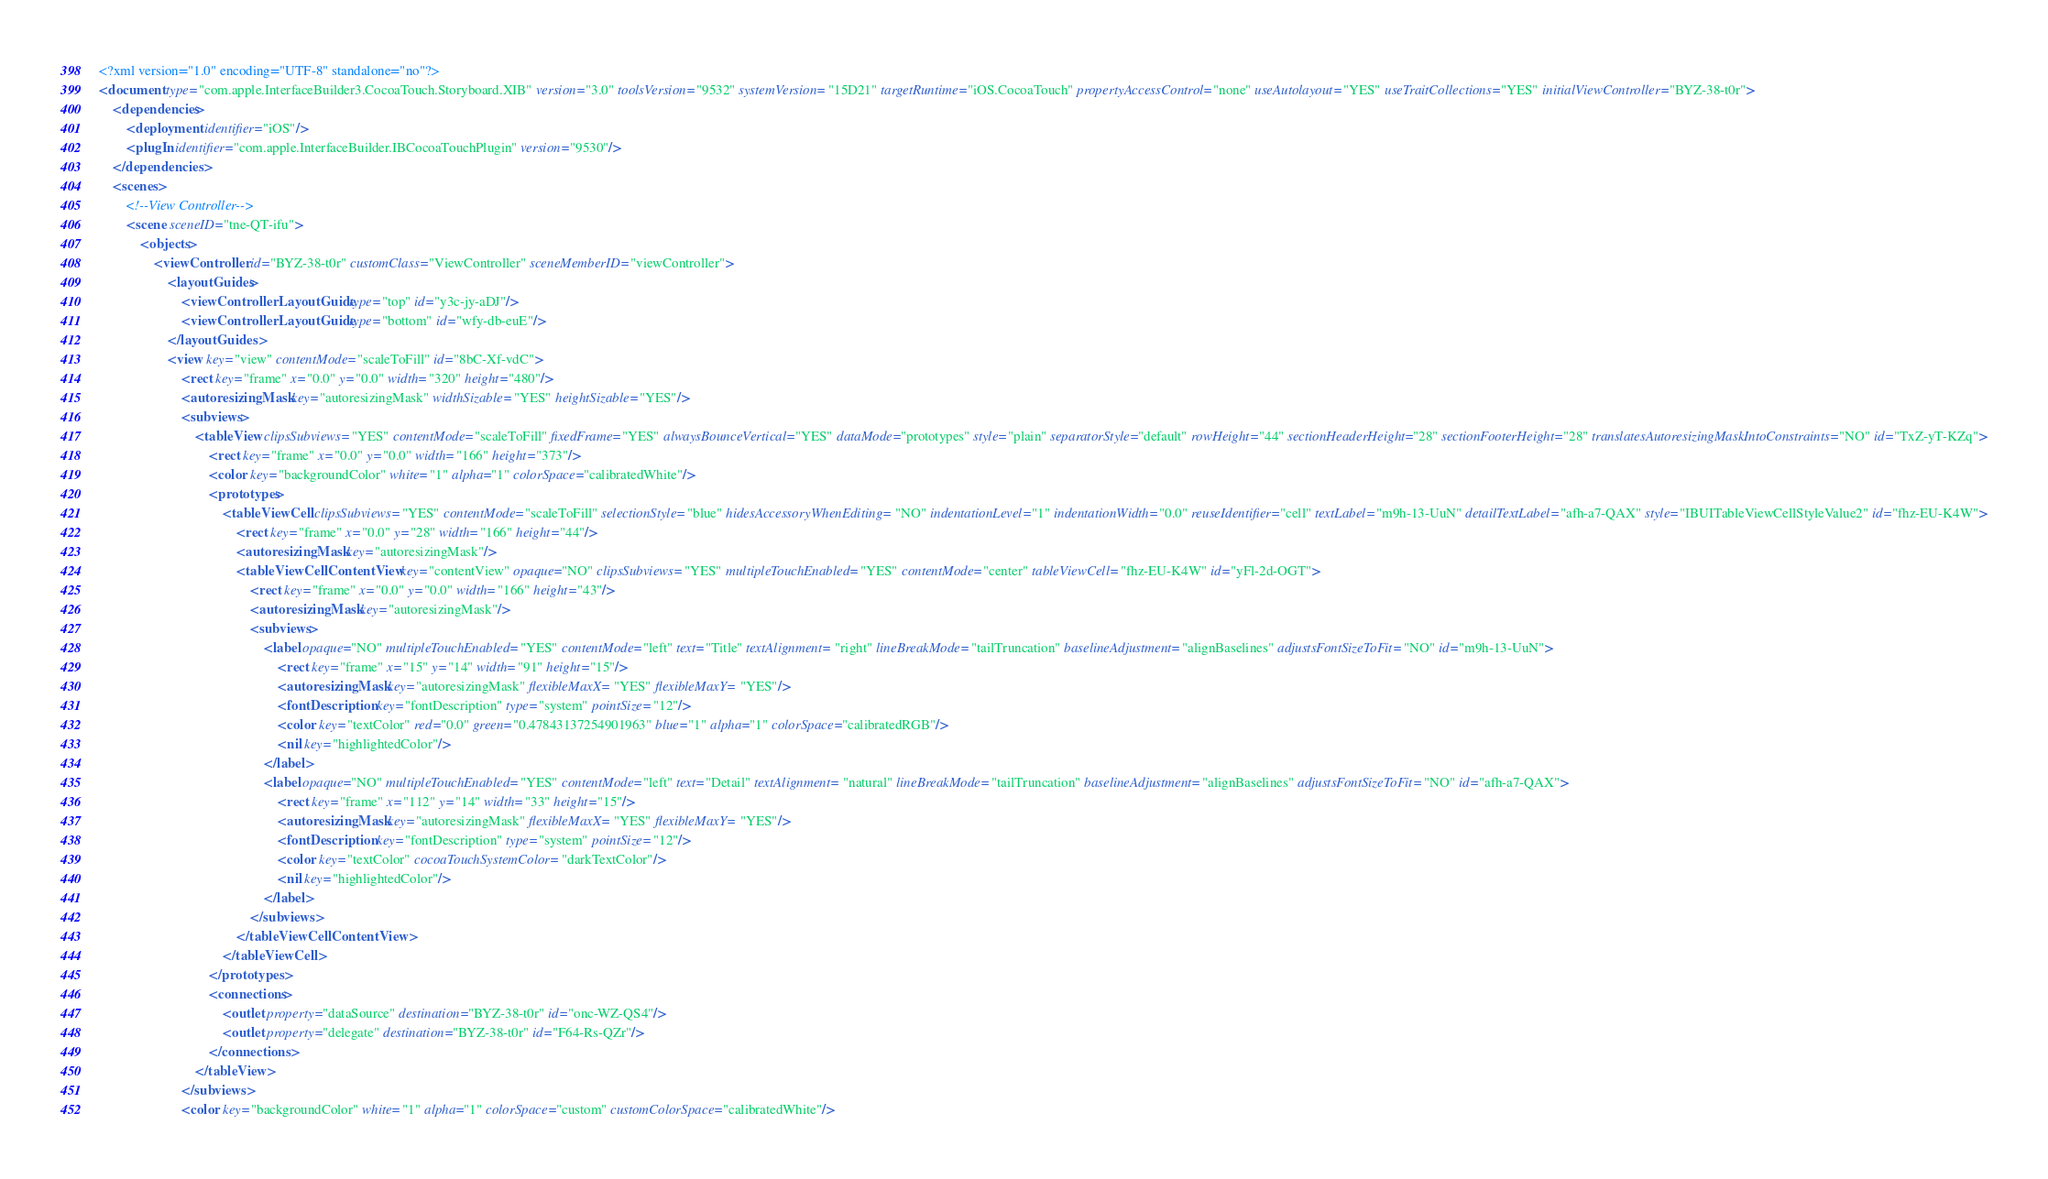Convert code to text. <code><loc_0><loc_0><loc_500><loc_500><_XML_><?xml version="1.0" encoding="UTF-8" standalone="no"?>
<document type="com.apple.InterfaceBuilder3.CocoaTouch.Storyboard.XIB" version="3.0" toolsVersion="9532" systemVersion="15D21" targetRuntime="iOS.CocoaTouch" propertyAccessControl="none" useAutolayout="YES" useTraitCollections="YES" initialViewController="BYZ-38-t0r">
    <dependencies>
        <deployment identifier="iOS"/>
        <plugIn identifier="com.apple.InterfaceBuilder.IBCocoaTouchPlugin" version="9530"/>
    </dependencies>
    <scenes>
        <!--View Controller-->
        <scene sceneID="tne-QT-ifu">
            <objects>
                <viewController id="BYZ-38-t0r" customClass="ViewController" sceneMemberID="viewController">
                    <layoutGuides>
                        <viewControllerLayoutGuide type="top" id="y3c-jy-aDJ"/>
                        <viewControllerLayoutGuide type="bottom" id="wfy-db-euE"/>
                    </layoutGuides>
                    <view key="view" contentMode="scaleToFill" id="8bC-Xf-vdC">
                        <rect key="frame" x="0.0" y="0.0" width="320" height="480"/>
                        <autoresizingMask key="autoresizingMask" widthSizable="YES" heightSizable="YES"/>
                        <subviews>
                            <tableView clipsSubviews="YES" contentMode="scaleToFill" fixedFrame="YES" alwaysBounceVertical="YES" dataMode="prototypes" style="plain" separatorStyle="default" rowHeight="44" sectionHeaderHeight="28" sectionFooterHeight="28" translatesAutoresizingMaskIntoConstraints="NO" id="TxZ-yT-KZq">
                                <rect key="frame" x="0.0" y="0.0" width="166" height="373"/>
                                <color key="backgroundColor" white="1" alpha="1" colorSpace="calibratedWhite"/>
                                <prototypes>
                                    <tableViewCell clipsSubviews="YES" contentMode="scaleToFill" selectionStyle="blue" hidesAccessoryWhenEditing="NO" indentationLevel="1" indentationWidth="0.0" reuseIdentifier="cell" textLabel="m9h-13-UuN" detailTextLabel="afh-a7-QAX" style="IBUITableViewCellStyleValue2" id="fhz-EU-K4W">
                                        <rect key="frame" x="0.0" y="28" width="166" height="44"/>
                                        <autoresizingMask key="autoresizingMask"/>
                                        <tableViewCellContentView key="contentView" opaque="NO" clipsSubviews="YES" multipleTouchEnabled="YES" contentMode="center" tableViewCell="fhz-EU-K4W" id="yFl-2d-OGT">
                                            <rect key="frame" x="0.0" y="0.0" width="166" height="43"/>
                                            <autoresizingMask key="autoresizingMask"/>
                                            <subviews>
                                                <label opaque="NO" multipleTouchEnabled="YES" contentMode="left" text="Title" textAlignment="right" lineBreakMode="tailTruncation" baselineAdjustment="alignBaselines" adjustsFontSizeToFit="NO" id="m9h-13-UuN">
                                                    <rect key="frame" x="15" y="14" width="91" height="15"/>
                                                    <autoresizingMask key="autoresizingMask" flexibleMaxX="YES" flexibleMaxY="YES"/>
                                                    <fontDescription key="fontDescription" type="system" pointSize="12"/>
                                                    <color key="textColor" red="0.0" green="0.47843137254901963" blue="1" alpha="1" colorSpace="calibratedRGB"/>
                                                    <nil key="highlightedColor"/>
                                                </label>
                                                <label opaque="NO" multipleTouchEnabled="YES" contentMode="left" text="Detail" textAlignment="natural" lineBreakMode="tailTruncation" baselineAdjustment="alignBaselines" adjustsFontSizeToFit="NO" id="afh-a7-QAX">
                                                    <rect key="frame" x="112" y="14" width="33" height="15"/>
                                                    <autoresizingMask key="autoresizingMask" flexibleMaxX="YES" flexibleMaxY="YES"/>
                                                    <fontDescription key="fontDescription" type="system" pointSize="12"/>
                                                    <color key="textColor" cocoaTouchSystemColor="darkTextColor"/>
                                                    <nil key="highlightedColor"/>
                                                </label>
                                            </subviews>
                                        </tableViewCellContentView>
                                    </tableViewCell>
                                </prototypes>
                                <connections>
                                    <outlet property="dataSource" destination="BYZ-38-t0r" id="onc-WZ-QS4"/>
                                    <outlet property="delegate" destination="BYZ-38-t0r" id="F64-Rs-QZr"/>
                                </connections>
                            </tableView>
                        </subviews>
                        <color key="backgroundColor" white="1" alpha="1" colorSpace="custom" customColorSpace="calibratedWhite"/></code> 